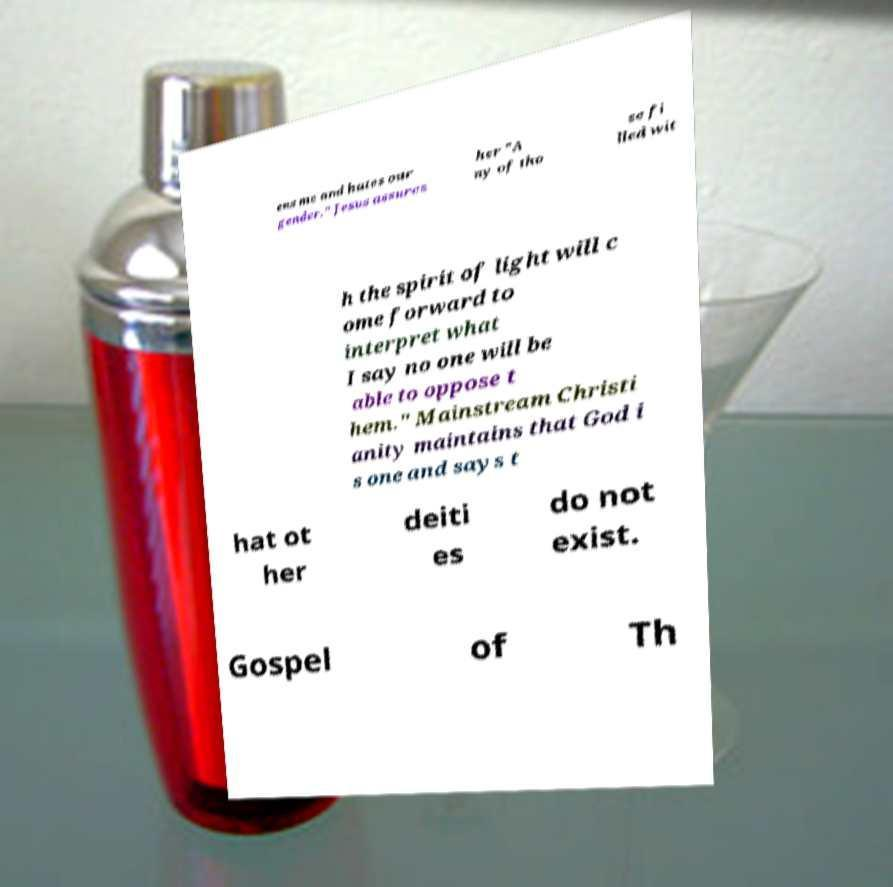What messages or text are displayed in this image? I need them in a readable, typed format. ens me and hates our gender." Jesus assures her "A ny of tho se fi lled wit h the spirit of light will c ome forward to interpret what I say no one will be able to oppose t hem." Mainstream Christi anity maintains that God i s one and says t hat ot her deiti es do not exist. Gospel of Th 